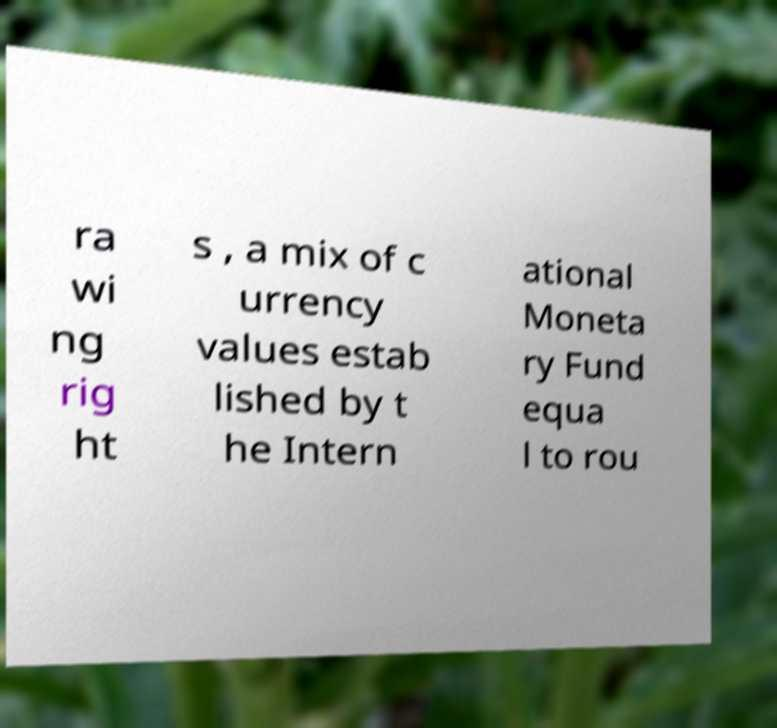Could you assist in decoding the text presented in this image and type it out clearly? ra wi ng rig ht s , a mix of c urrency values estab lished by t he Intern ational Moneta ry Fund equa l to rou 